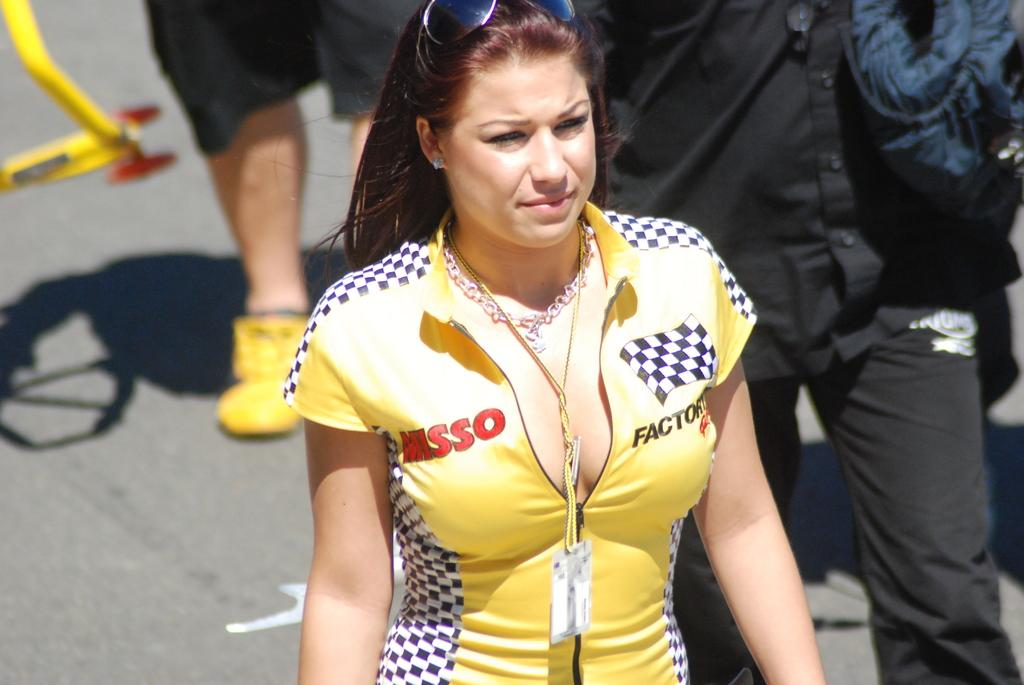<image>
Give a short and clear explanation of the subsequent image. A woman race car drive with Misso on her outfit. 